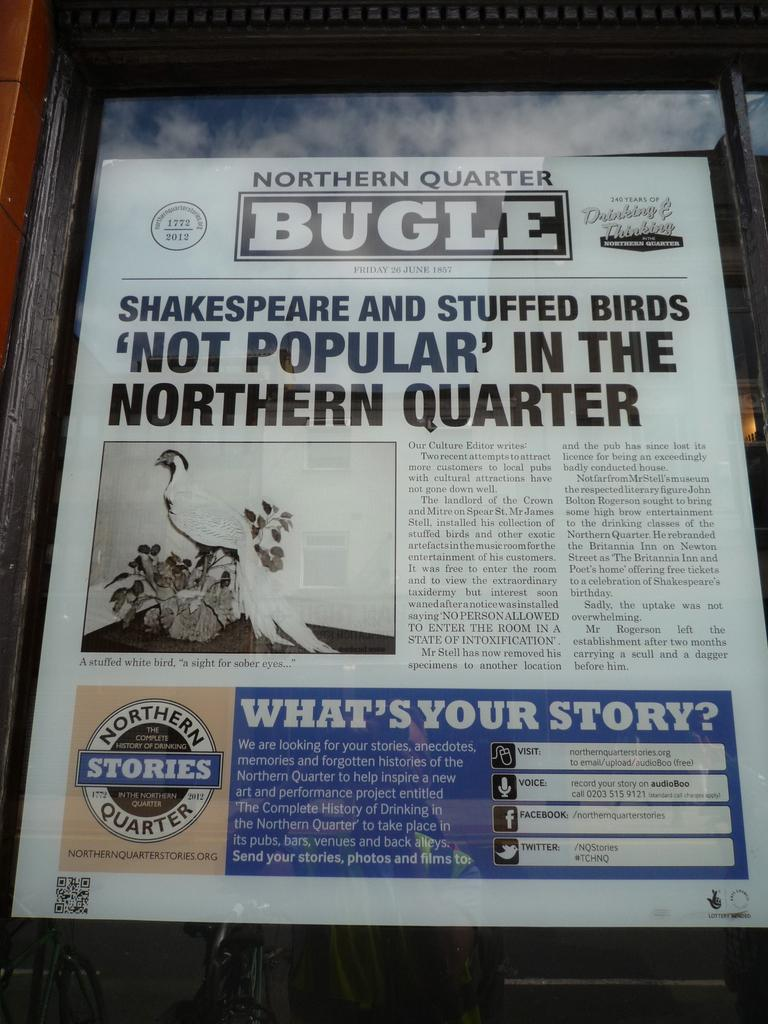Provide a one-sentence caption for the provided image. The front page of the Norther Quarter Bugle on display. 